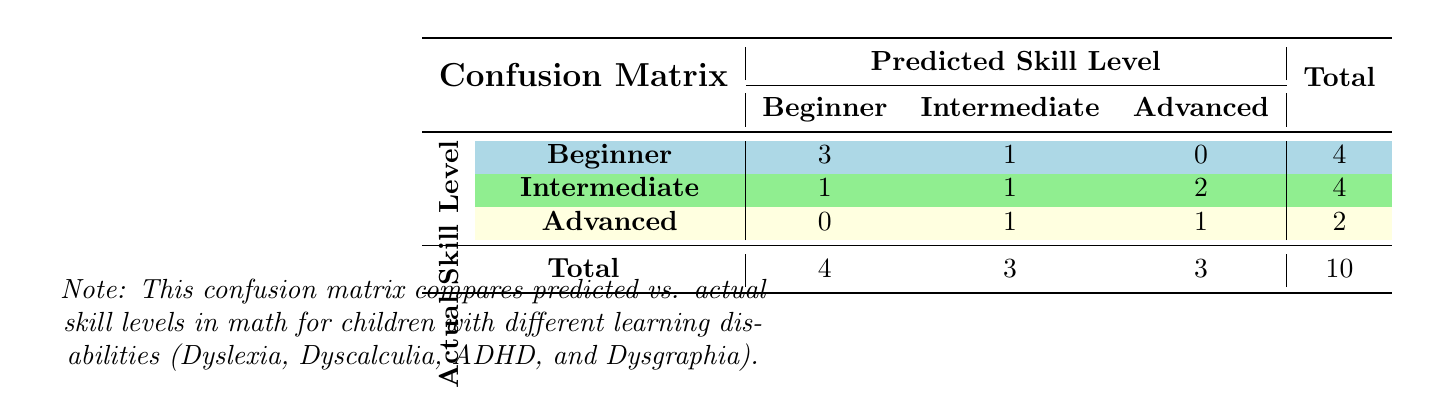What is the total number of children whose actual skill level is Beginner? From the confusion matrix, we can see the row for "Actual Skill Level" being Beginner has a total of 4 children (3 predicted Beginner and 1 predicted Intermediate).
Answer: 4 How many children were predicted to have an Intermediate skill level? To find the total predicted as Intermediate, we sum the values in the Intermediate column across all rows: 1 (actual Beginner) + 1 (actual Intermediate) + 1 (actual Advanced) = 3.
Answer: 3 Did any children with a predicted skill level of Advanced have an actual skill level of Beginner? Looking at the column for predicted Advanced and checking the corresponding actual levels, we see that there are no entries under actual Beginner. Therefore, the answer is no.
Answer: No What is the total number of predicted skill levels across all learning disabilities? Sum the total values in the last column, which gives 10 (4 for Beginner, 4 for Intermediate, and 2 for Advanced).
Answer: 10 How many children are predicted as Intermediate with an actual skill level of Advanced? In the confusion matrix, we look at the row for actual Advanced and check the Intermediate column, which has 1 child predicted as Intermediate.
Answer: 1 What is the difference in the number of children predicted as Beginner versus Advanced? The number predicted as Beginner is 4, and the number predicted as Advanced is 3. The difference is 4 - 3 = 1.
Answer: 1 Is it true that more children were predicted as Advanced than as Intermediate? We see that there are 3 children predicted as Advanced and 4 children predicted as Intermediate. Hence, the statement is false.
Answer: No What percentage of children with a predicted skill level of Beginner actually achieved Beginner? The count for Beginner predicted is 4 (3 actual Beginner + 1 actual Intermediate). Out of these, 3 are correct predictions. So, the percentage is (3/4) * 100 = 75%.
Answer: 75% 